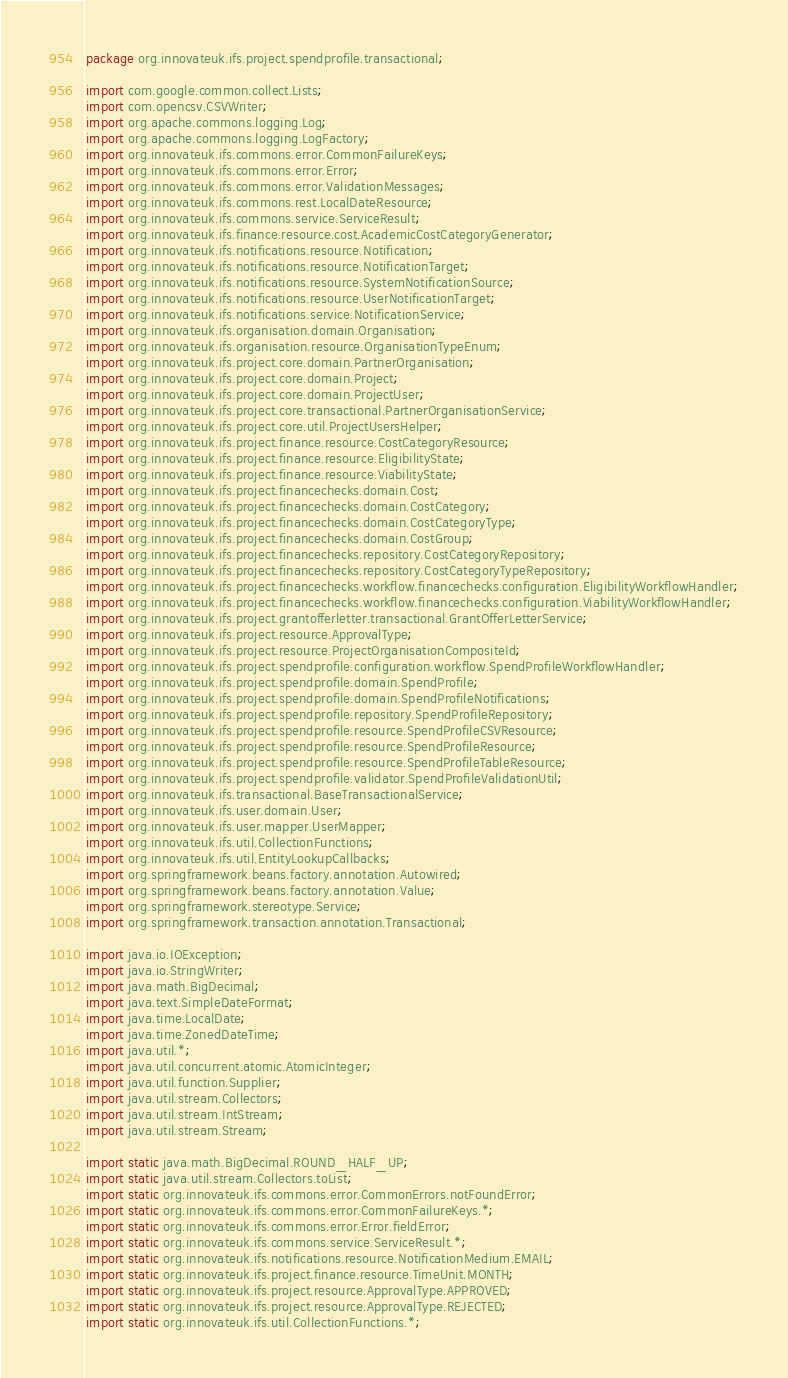Convert code to text. <code><loc_0><loc_0><loc_500><loc_500><_Java_>package org.innovateuk.ifs.project.spendprofile.transactional;

import com.google.common.collect.Lists;
import com.opencsv.CSVWriter;
import org.apache.commons.logging.Log;
import org.apache.commons.logging.LogFactory;
import org.innovateuk.ifs.commons.error.CommonFailureKeys;
import org.innovateuk.ifs.commons.error.Error;
import org.innovateuk.ifs.commons.error.ValidationMessages;
import org.innovateuk.ifs.commons.rest.LocalDateResource;
import org.innovateuk.ifs.commons.service.ServiceResult;
import org.innovateuk.ifs.finance.resource.cost.AcademicCostCategoryGenerator;
import org.innovateuk.ifs.notifications.resource.Notification;
import org.innovateuk.ifs.notifications.resource.NotificationTarget;
import org.innovateuk.ifs.notifications.resource.SystemNotificationSource;
import org.innovateuk.ifs.notifications.resource.UserNotificationTarget;
import org.innovateuk.ifs.notifications.service.NotificationService;
import org.innovateuk.ifs.organisation.domain.Organisation;
import org.innovateuk.ifs.organisation.resource.OrganisationTypeEnum;
import org.innovateuk.ifs.project.core.domain.PartnerOrganisation;
import org.innovateuk.ifs.project.core.domain.Project;
import org.innovateuk.ifs.project.core.domain.ProjectUser;
import org.innovateuk.ifs.project.core.transactional.PartnerOrganisationService;
import org.innovateuk.ifs.project.core.util.ProjectUsersHelper;
import org.innovateuk.ifs.project.finance.resource.CostCategoryResource;
import org.innovateuk.ifs.project.finance.resource.EligibilityState;
import org.innovateuk.ifs.project.finance.resource.ViabilityState;
import org.innovateuk.ifs.project.financechecks.domain.Cost;
import org.innovateuk.ifs.project.financechecks.domain.CostCategory;
import org.innovateuk.ifs.project.financechecks.domain.CostCategoryType;
import org.innovateuk.ifs.project.financechecks.domain.CostGroup;
import org.innovateuk.ifs.project.financechecks.repository.CostCategoryRepository;
import org.innovateuk.ifs.project.financechecks.repository.CostCategoryTypeRepository;
import org.innovateuk.ifs.project.financechecks.workflow.financechecks.configuration.EligibilityWorkflowHandler;
import org.innovateuk.ifs.project.financechecks.workflow.financechecks.configuration.ViabilityWorkflowHandler;
import org.innovateuk.ifs.project.grantofferletter.transactional.GrantOfferLetterService;
import org.innovateuk.ifs.project.resource.ApprovalType;
import org.innovateuk.ifs.project.resource.ProjectOrganisationCompositeId;
import org.innovateuk.ifs.project.spendprofile.configuration.workflow.SpendProfileWorkflowHandler;
import org.innovateuk.ifs.project.spendprofile.domain.SpendProfile;
import org.innovateuk.ifs.project.spendprofile.domain.SpendProfileNotifications;
import org.innovateuk.ifs.project.spendprofile.repository.SpendProfileRepository;
import org.innovateuk.ifs.project.spendprofile.resource.SpendProfileCSVResource;
import org.innovateuk.ifs.project.spendprofile.resource.SpendProfileResource;
import org.innovateuk.ifs.project.spendprofile.resource.SpendProfileTableResource;
import org.innovateuk.ifs.project.spendprofile.validator.SpendProfileValidationUtil;
import org.innovateuk.ifs.transactional.BaseTransactionalService;
import org.innovateuk.ifs.user.domain.User;
import org.innovateuk.ifs.user.mapper.UserMapper;
import org.innovateuk.ifs.util.CollectionFunctions;
import org.innovateuk.ifs.util.EntityLookupCallbacks;
import org.springframework.beans.factory.annotation.Autowired;
import org.springframework.beans.factory.annotation.Value;
import org.springframework.stereotype.Service;
import org.springframework.transaction.annotation.Transactional;

import java.io.IOException;
import java.io.StringWriter;
import java.math.BigDecimal;
import java.text.SimpleDateFormat;
import java.time.LocalDate;
import java.time.ZonedDateTime;
import java.util.*;
import java.util.concurrent.atomic.AtomicInteger;
import java.util.function.Supplier;
import java.util.stream.Collectors;
import java.util.stream.IntStream;
import java.util.stream.Stream;

import static java.math.BigDecimal.ROUND_HALF_UP;
import static java.util.stream.Collectors.toList;
import static org.innovateuk.ifs.commons.error.CommonErrors.notFoundError;
import static org.innovateuk.ifs.commons.error.CommonFailureKeys.*;
import static org.innovateuk.ifs.commons.error.Error.fieldError;
import static org.innovateuk.ifs.commons.service.ServiceResult.*;
import static org.innovateuk.ifs.notifications.resource.NotificationMedium.EMAIL;
import static org.innovateuk.ifs.project.finance.resource.TimeUnit.MONTH;
import static org.innovateuk.ifs.project.resource.ApprovalType.APPROVED;
import static org.innovateuk.ifs.project.resource.ApprovalType.REJECTED;
import static org.innovateuk.ifs.util.CollectionFunctions.*;</code> 